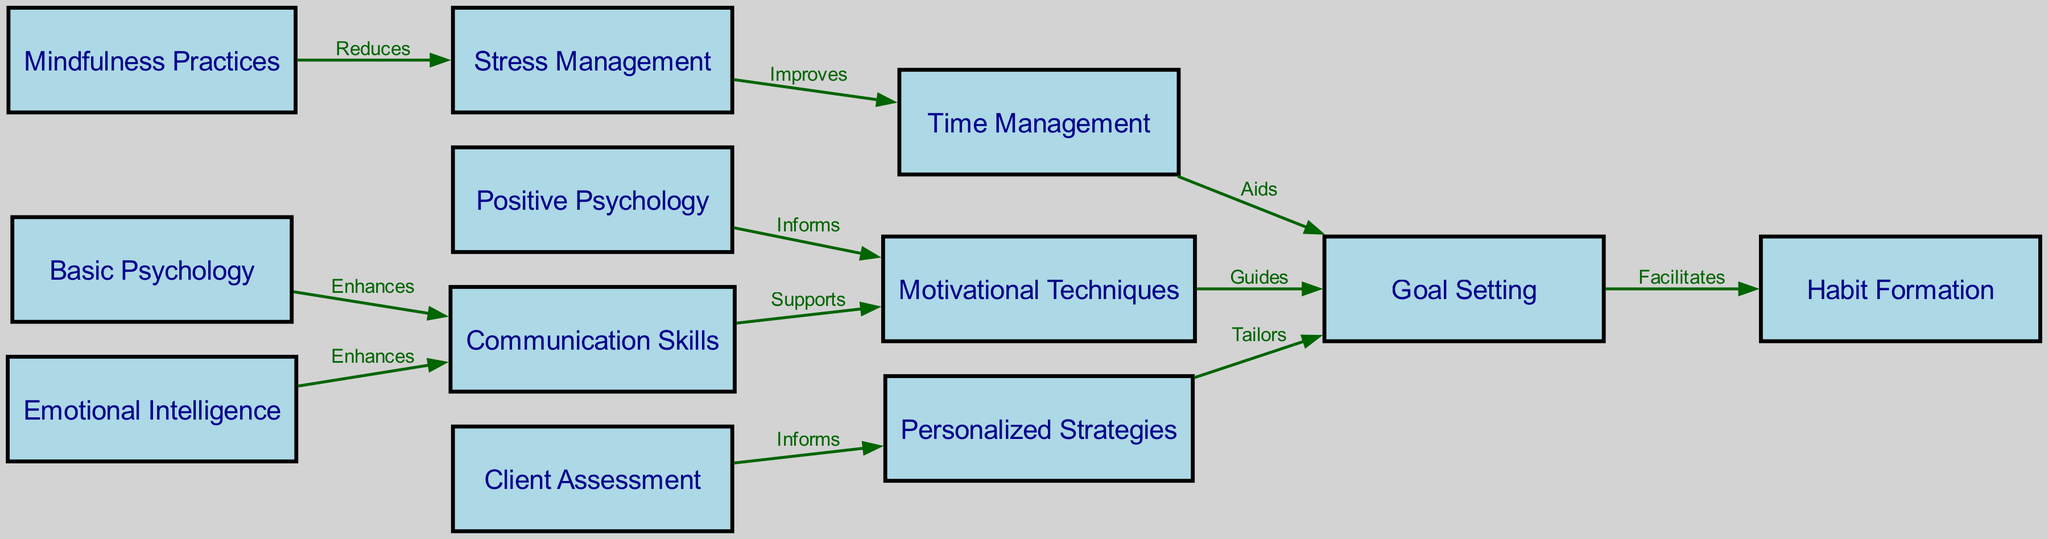What is the total number of nodes in the diagram? The total number of nodes can be counted directly from the list of nodes provided. There are 12 unique concepts listed.
Answer: 12 Which node is connected to "Time Management"? By examining the edges, "Time Management" has direct edges leading to "Goal Setting," showing it's the node connected to it.
Answer: Goal Setting What label describes the connection from "Motivational Techniques" to "Goal Setting"? Inspecting the edge from "Motivational Techniques" to "Goal Setting," we find the label that signifies their relationship is "Guides."
Answer: Guides Which two nodes directly support "Client Assessment"? Looking at the diagram, "Client Assessment" has directed edges leading to "Personalized Strategies." Since it is the only connection, there are no other nodes supporting it directly.
Answer: Personalized Strategies How does "Stress Management" affect "Time Management"? The edge from "Stress Management" to "Time Management" indicates that it "Improves" this node, suggesting a positive impact.
Answer: Improves What is the flow from "Mindfulness Practices" to "Goal Setting"? Tracing the flow requires looking at the connections. "Mindfulness Practices" connects to "Stress Management," which then connects to "Time Management." The flow continues to "Goal Setting" through a subsequent edge.
Answer: Mindfulness Practices -> Stress Management -> Time Management -> Goal Setting How many edges are directed from "Positive Psychology"? By examining the edges, it can be identified that "Positive Psychology" has one directed edge leading to "Motivational Techniques."
Answer: 1 What is the relationship between "Basic Psychology" and "Motivational Techniques"? The diagram points out that "Basic Psychology" enhances "Communication Skills," and those skills then support "Motivational Techniques." Hence, the connection is indirect via another node.
Answer: Indirect (via Communication Skills) Which node acts both as a base and an aid in the goal-setting process? Analyzing the diagram shows that both "Time Management" (which aids goal setting) and "Habit Formation" (which builds on it) fit this criteria, but "Goal Setting" is the central node in this context.
Answer: Goal Setting 